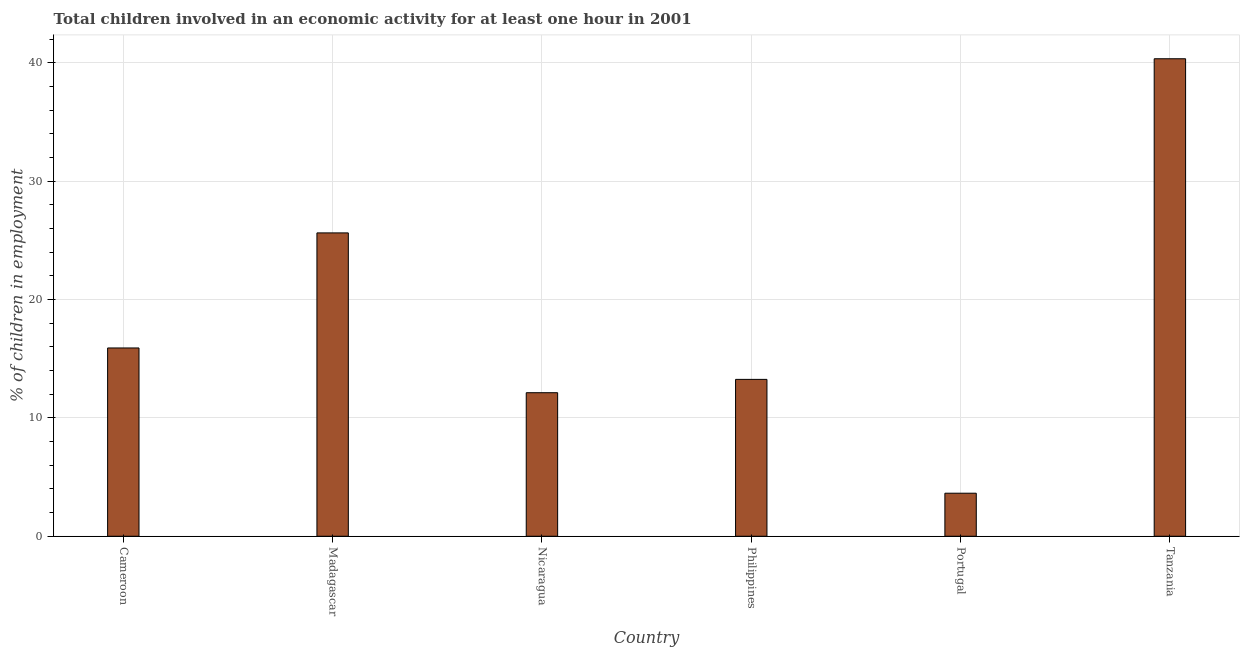What is the title of the graph?
Make the answer very short. Total children involved in an economic activity for at least one hour in 2001. What is the label or title of the X-axis?
Keep it short and to the point. Country. What is the label or title of the Y-axis?
Provide a succinct answer. % of children in employment. What is the percentage of children in employment in Nicaragua?
Your answer should be very brief. 12.13. Across all countries, what is the maximum percentage of children in employment?
Make the answer very short. 40.35. Across all countries, what is the minimum percentage of children in employment?
Provide a short and direct response. 3.64. In which country was the percentage of children in employment maximum?
Provide a succinct answer. Tanzania. In which country was the percentage of children in employment minimum?
Your answer should be compact. Portugal. What is the sum of the percentage of children in employment?
Provide a short and direct response. 110.92. What is the difference between the percentage of children in employment in Nicaragua and Portugal?
Your answer should be compact. 8.49. What is the average percentage of children in employment per country?
Keep it short and to the point. 18.49. What is the median percentage of children in employment?
Your answer should be compact. 14.58. In how many countries, is the percentage of children in employment greater than 32 %?
Provide a succinct answer. 1. What is the ratio of the percentage of children in employment in Portugal to that in Tanzania?
Give a very brief answer. 0.09. What is the difference between the highest and the second highest percentage of children in employment?
Offer a very short reply. 14.72. What is the difference between the highest and the lowest percentage of children in employment?
Your answer should be compact. 36.72. What is the % of children in employment in Cameroon?
Make the answer very short. 15.91. What is the % of children in employment of Madagascar?
Keep it short and to the point. 25.63. What is the % of children in employment of Nicaragua?
Your answer should be compact. 12.13. What is the % of children in employment in Philippines?
Make the answer very short. 13.26. What is the % of children in employment in Portugal?
Offer a very short reply. 3.64. What is the % of children in employment of Tanzania?
Ensure brevity in your answer.  40.35. What is the difference between the % of children in employment in Cameroon and Madagascar?
Provide a succinct answer. -9.72. What is the difference between the % of children in employment in Cameroon and Nicaragua?
Provide a succinct answer. 3.78. What is the difference between the % of children in employment in Cameroon and Philippines?
Ensure brevity in your answer.  2.65. What is the difference between the % of children in employment in Cameroon and Portugal?
Your response must be concise. 12.27. What is the difference between the % of children in employment in Cameroon and Tanzania?
Your answer should be compact. -24.44. What is the difference between the % of children in employment in Madagascar and Nicaragua?
Offer a terse response. 13.5. What is the difference between the % of children in employment in Madagascar and Philippines?
Give a very brief answer. 12.38. What is the difference between the % of children in employment in Madagascar and Portugal?
Offer a very short reply. 22. What is the difference between the % of children in employment in Madagascar and Tanzania?
Give a very brief answer. -14.72. What is the difference between the % of children in employment in Nicaragua and Philippines?
Your answer should be compact. -1.13. What is the difference between the % of children in employment in Nicaragua and Portugal?
Make the answer very short. 8.49. What is the difference between the % of children in employment in Nicaragua and Tanzania?
Ensure brevity in your answer.  -28.22. What is the difference between the % of children in employment in Philippines and Portugal?
Your answer should be compact. 9.62. What is the difference between the % of children in employment in Philippines and Tanzania?
Ensure brevity in your answer.  -27.1. What is the difference between the % of children in employment in Portugal and Tanzania?
Your response must be concise. -36.72. What is the ratio of the % of children in employment in Cameroon to that in Madagascar?
Your answer should be compact. 0.62. What is the ratio of the % of children in employment in Cameroon to that in Nicaragua?
Ensure brevity in your answer.  1.31. What is the ratio of the % of children in employment in Cameroon to that in Philippines?
Make the answer very short. 1.2. What is the ratio of the % of children in employment in Cameroon to that in Portugal?
Make the answer very short. 4.38. What is the ratio of the % of children in employment in Cameroon to that in Tanzania?
Give a very brief answer. 0.39. What is the ratio of the % of children in employment in Madagascar to that in Nicaragua?
Offer a very short reply. 2.11. What is the ratio of the % of children in employment in Madagascar to that in Philippines?
Make the answer very short. 1.93. What is the ratio of the % of children in employment in Madagascar to that in Portugal?
Offer a terse response. 7.05. What is the ratio of the % of children in employment in Madagascar to that in Tanzania?
Give a very brief answer. 0.64. What is the ratio of the % of children in employment in Nicaragua to that in Philippines?
Ensure brevity in your answer.  0.92. What is the ratio of the % of children in employment in Nicaragua to that in Portugal?
Provide a short and direct response. 3.34. What is the ratio of the % of children in employment in Nicaragua to that in Tanzania?
Your response must be concise. 0.3. What is the ratio of the % of children in employment in Philippines to that in Portugal?
Keep it short and to the point. 3.65. What is the ratio of the % of children in employment in Philippines to that in Tanzania?
Keep it short and to the point. 0.33. What is the ratio of the % of children in employment in Portugal to that in Tanzania?
Your answer should be compact. 0.09. 